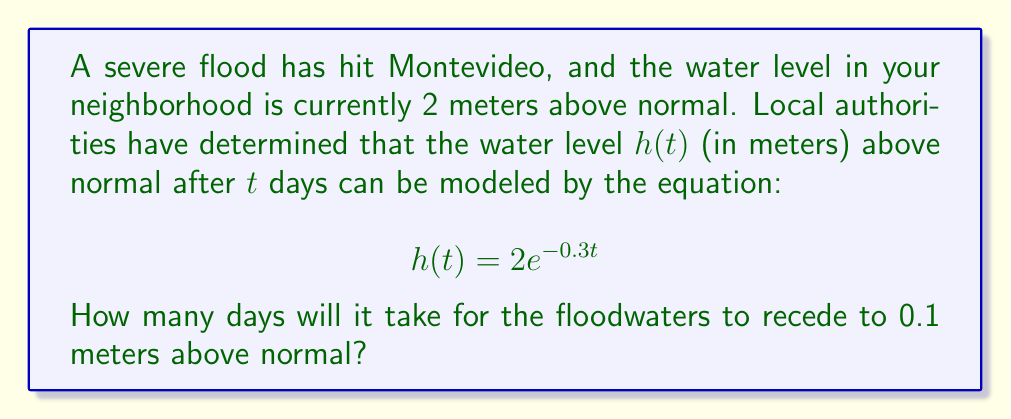Show me your answer to this math problem. To solve this problem, we need to use the given logarithmic function and solve for $t$ when $h(t) = 0.1$. Let's approach this step-by-step:

1) We start with the equation:
   $$h(t) = 2e^{-0.3t}$$

2) We want to find $t$ when $h(t) = 0.1$, so we set up the equation:
   $$0.1 = 2e^{-0.3t}$$

3) First, let's divide both sides by 2:
   $$0.05 = e^{-0.3t}$$

4) Now, we can take the natural logarithm of both sides. Remember, $\ln(e^x) = x$:
   $$\ln(0.05) = \ln(e^{-0.3t})$$
   $$\ln(0.05) = -0.3t$$

5) Solve for $t$ by dividing both sides by -0.3:
   $$t = \frac{\ln(0.05)}{-0.3}$$

6) Calculate the result:
   $$t = \frac{-2.9957}{-0.3} \approx 9.9857$$

Therefore, it will take approximately 10 days for the floodwaters to recede to 0.1 meters above normal.
Answer: Approximately 10 days 